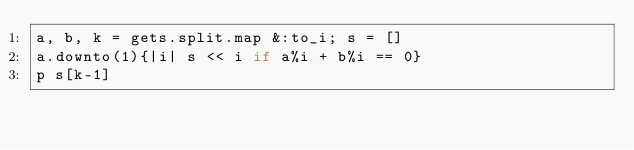Convert code to text. <code><loc_0><loc_0><loc_500><loc_500><_Ruby_>a, b, k = gets.split.map &:to_i; s = []
a.downto(1){|i| s << i if a%i + b%i == 0}
p s[k-1]</code> 